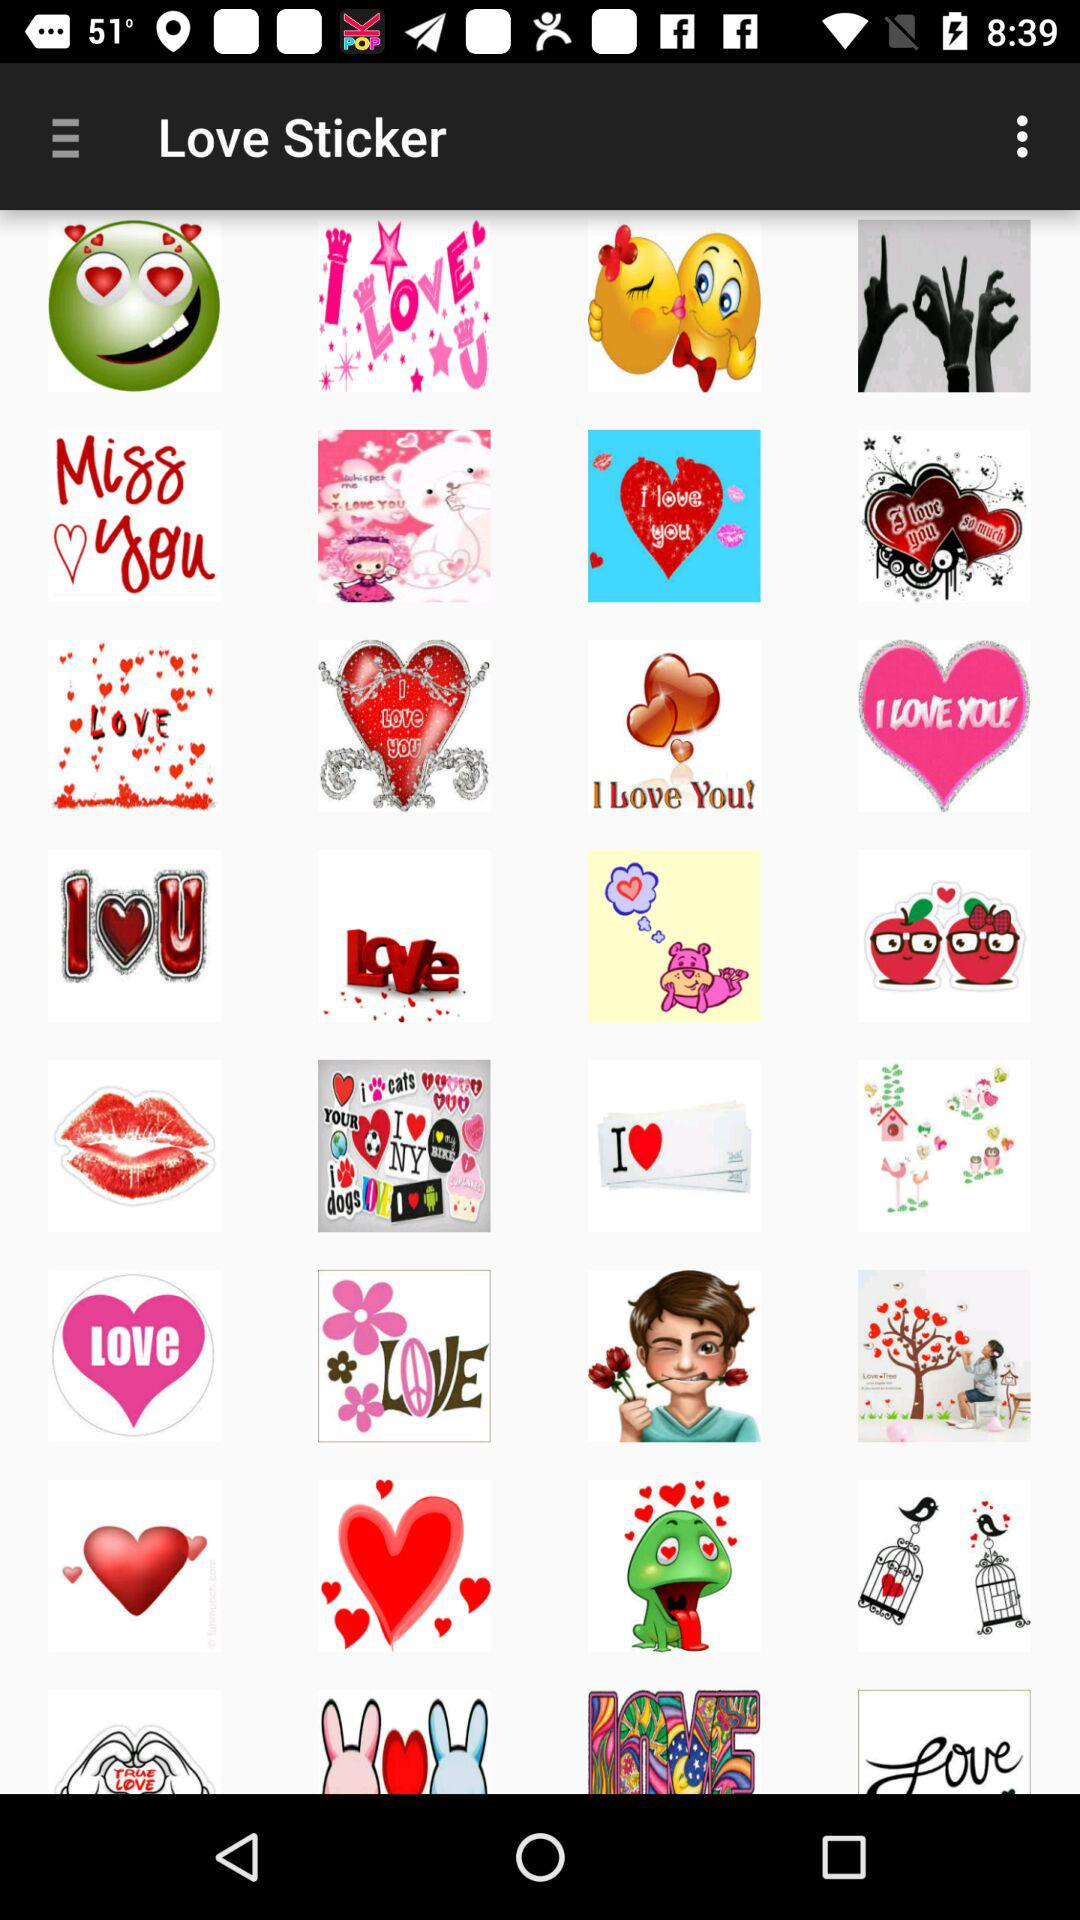What is the name of the application? The name of the application is "Love Sticker". 